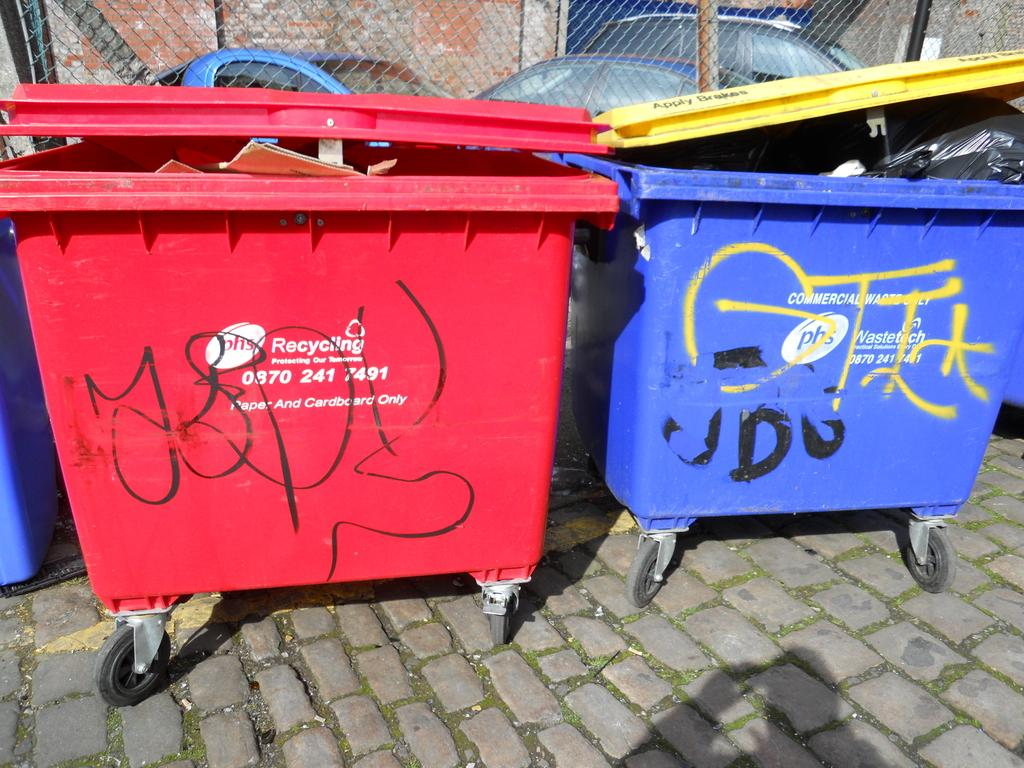Provide a one-sentence caption for the provided image. To garbage cans from PHS Recycling covered in grafitti. 